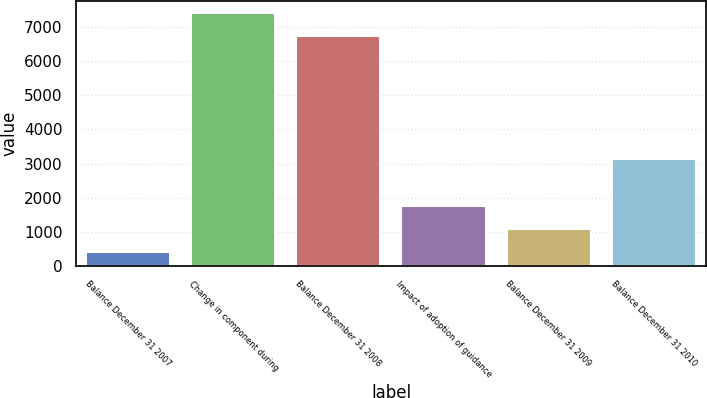Convert chart. <chart><loc_0><loc_0><loc_500><loc_500><bar_chart><fcel>Balance December 31 2007<fcel>Change in component during<fcel>Balance December 31 2008<fcel>Impact of adoption of guidance<fcel>Balance December 31 2009<fcel>Balance December 31 2010<nl><fcel>400<fcel>7408.5<fcel>6735<fcel>1747<fcel>1073.5<fcel>3145<nl></chart> 